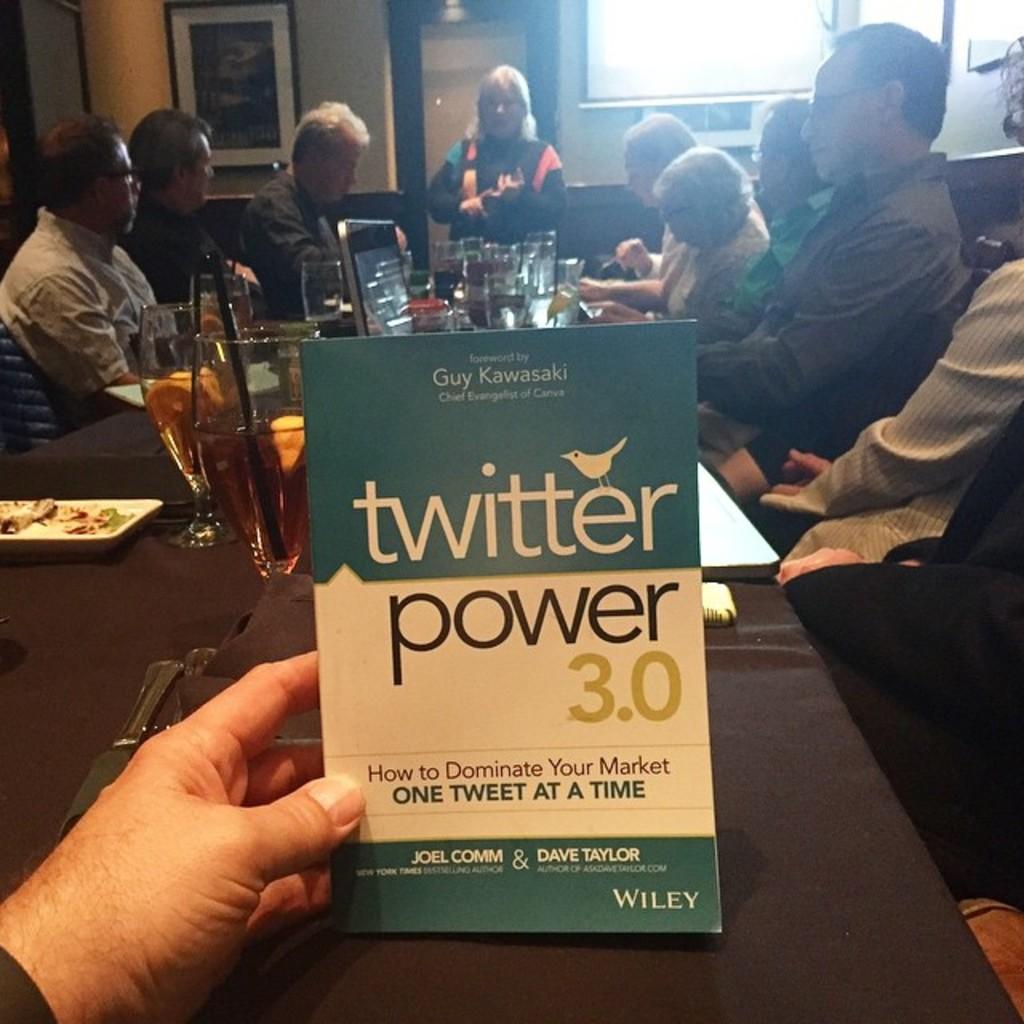Who are the authors of this book?
Your answer should be very brief. Joel comm and dave taylor. What platfrom is this book ment to help you with?
Offer a terse response. Twitter. 